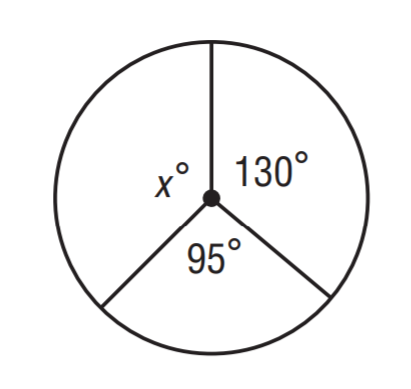Answer the mathemtical geometry problem and directly provide the correct option letter.
Question: Find x.
Choices: A: 120 B: 135 C: 145 D: 160 B 